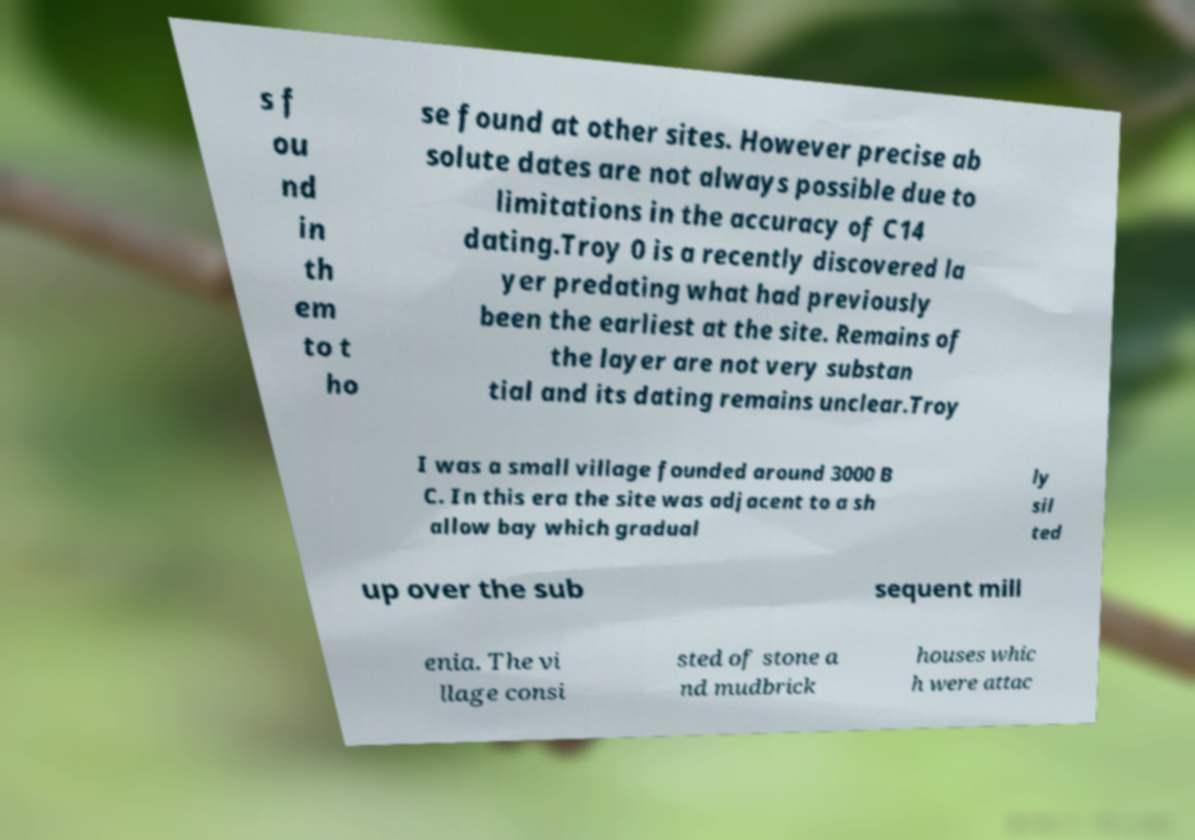Could you extract and type out the text from this image? s f ou nd in th em to t ho se found at other sites. However precise ab solute dates are not always possible due to limitations in the accuracy of C14 dating.Troy 0 is a recently discovered la yer predating what had previously been the earliest at the site. Remains of the layer are not very substan tial and its dating remains unclear.Troy I was a small village founded around 3000 B C. In this era the site was adjacent to a sh allow bay which gradual ly sil ted up over the sub sequent mill enia. The vi llage consi sted of stone a nd mudbrick houses whic h were attac 